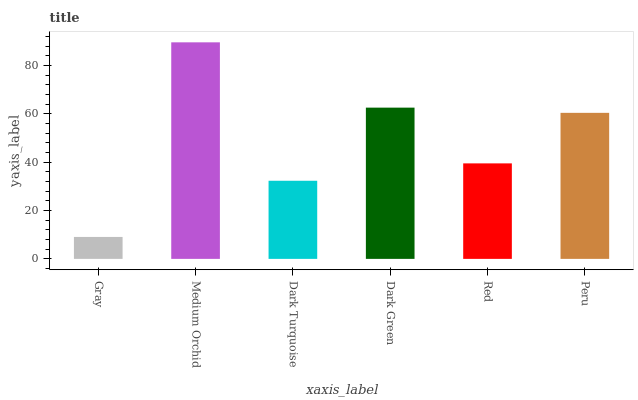Is Gray the minimum?
Answer yes or no. Yes. Is Medium Orchid the maximum?
Answer yes or no. Yes. Is Dark Turquoise the minimum?
Answer yes or no. No. Is Dark Turquoise the maximum?
Answer yes or no. No. Is Medium Orchid greater than Dark Turquoise?
Answer yes or no. Yes. Is Dark Turquoise less than Medium Orchid?
Answer yes or no. Yes. Is Dark Turquoise greater than Medium Orchid?
Answer yes or no. No. Is Medium Orchid less than Dark Turquoise?
Answer yes or no. No. Is Peru the high median?
Answer yes or no. Yes. Is Red the low median?
Answer yes or no. Yes. Is Gray the high median?
Answer yes or no. No. Is Medium Orchid the low median?
Answer yes or no. No. 